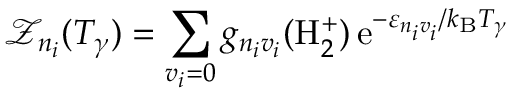<formula> <loc_0><loc_0><loc_500><loc_500>\mathcal { Z } _ { n _ { i } } ( T _ { \gamma } ) = \sum _ { v _ { i } = 0 } g _ { n _ { i } v _ { i } } ( H _ { 2 } ^ { + } ) \, e ^ { - \varepsilon _ { n _ { i } v _ { i } } / k _ { B } T _ { \gamma } }</formula> 